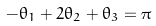<formula> <loc_0><loc_0><loc_500><loc_500>- \theta _ { 1 } + 2 \theta _ { 2 } + \theta _ { 3 } = \pi</formula> 